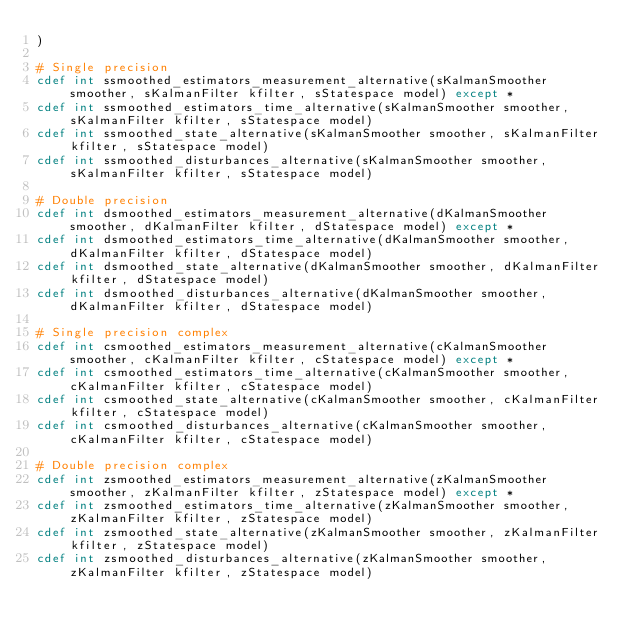Convert code to text. <code><loc_0><loc_0><loc_500><loc_500><_Cython_>)

# Single precision
cdef int ssmoothed_estimators_measurement_alternative(sKalmanSmoother smoother, sKalmanFilter kfilter, sStatespace model) except *
cdef int ssmoothed_estimators_time_alternative(sKalmanSmoother smoother, sKalmanFilter kfilter, sStatespace model)
cdef int ssmoothed_state_alternative(sKalmanSmoother smoother, sKalmanFilter kfilter, sStatespace model)
cdef int ssmoothed_disturbances_alternative(sKalmanSmoother smoother, sKalmanFilter kfilter, sStatespace model)

# Double precision
cdef int dsmoothed_estimators_measurement_alternative(dKalmanSmoother smoother, dKalmanFilter kfilter, dStatespace model) except *
cdef int dsmoothed_estimators_time_alternative(dKalmanSmoother smoother, dKalmanFilter kfilter, dStatespace model)
cdef int dsmoothed_state_alternative(dKalmanSmoother smoother, dKalmanFilter kfilter, dStatespace model)
cdef int dsmoothed_disturbances_alternative(dKalmanSmoother smoother, dKalmanFilter kfilter, dStatespace model)

# Single precision complex
cdef int csmoothed_estimators_measurement_alternative(cKalmanSmoother smoother, cKalmanFilter kfilter, cStatespace model) except *
cdef int csmoothed_estimators_time_alternative(cKalmanSmoother smoother, cKalmanFilter kfilter, cStatespace model)
cdef int csmoothed_state_alternative(cKalmanSmoother smoother, cKalmanFilter kfilter, cStatespace model)
cdef int csmoothed_disturbances_alternative(cKalmanSmoother smoother, cKalmanFilter kfilter, cStatespace model)

# Double precision complex
cdef int zsmoothed_estimators_measurement_alternative(zKalmanSmoother smoother, zKalmanFilter kfilter, zStatespace model) except *
cdef int zsmoothed_estimators_time_alternative(zKalmanSmoother smoother, zKalmanFilter kfilter, zStatespace model)
cdef int zsmoothed_state_alternative(zKalmanSmoother smoother, zKalmanFilter kfilter, zStatespace model)
cdef int zsmoothed_disturbances_alternative(zKalmanSmoother smoother, zKalmanFilter kfilter, zStatespace model)
</code> 